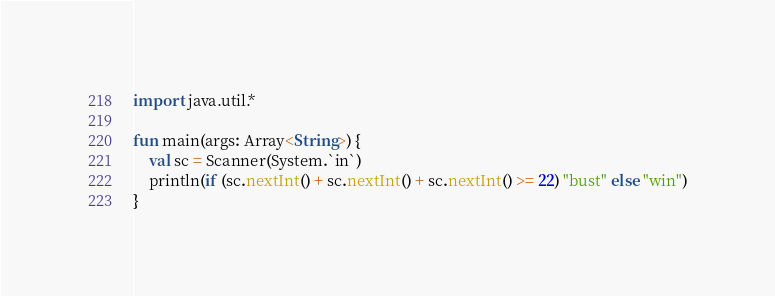<code> <loc_0><loc_0><loc_500><loc_500><_Kotlin_>import java.util.*
 
fun main(args: Array<String>) {
    val sc = Scanner(System.`in`)
    println(if (sc.nextInt() + sc.nextInt() + sc.nextInt() >= 22) "bust" else "win")
}</code> 